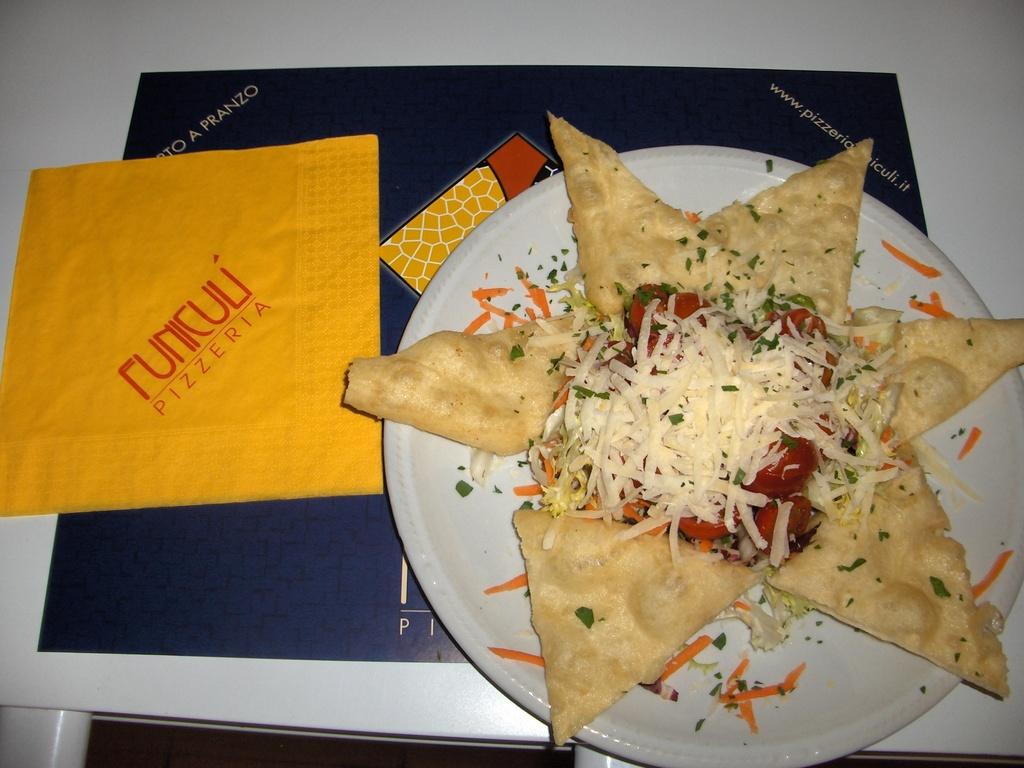What type of food is this?
Make the answer very short. Pizza. What does the napkin say on it?
Offer a very short reply. Funiculi pizzeria. 